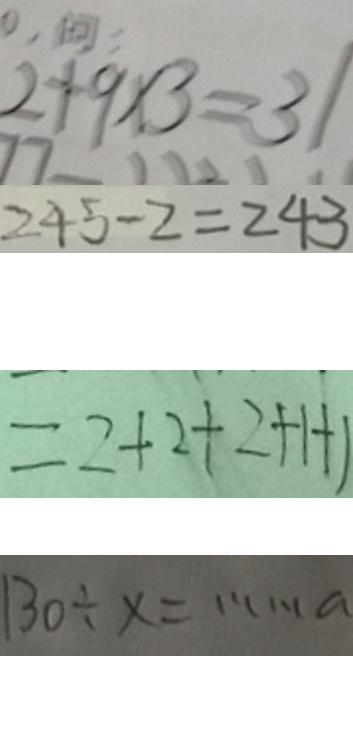<formula> <loc_0><loc_0><loc_500><loc_500>2 + 9 \times 3 = 3 1 
 2 4 5 - 2 = 2 4 3 
 = 2 + 2 + 2 + 1 + 1 
 1 3 0 \div x = \cdots a</formula> 